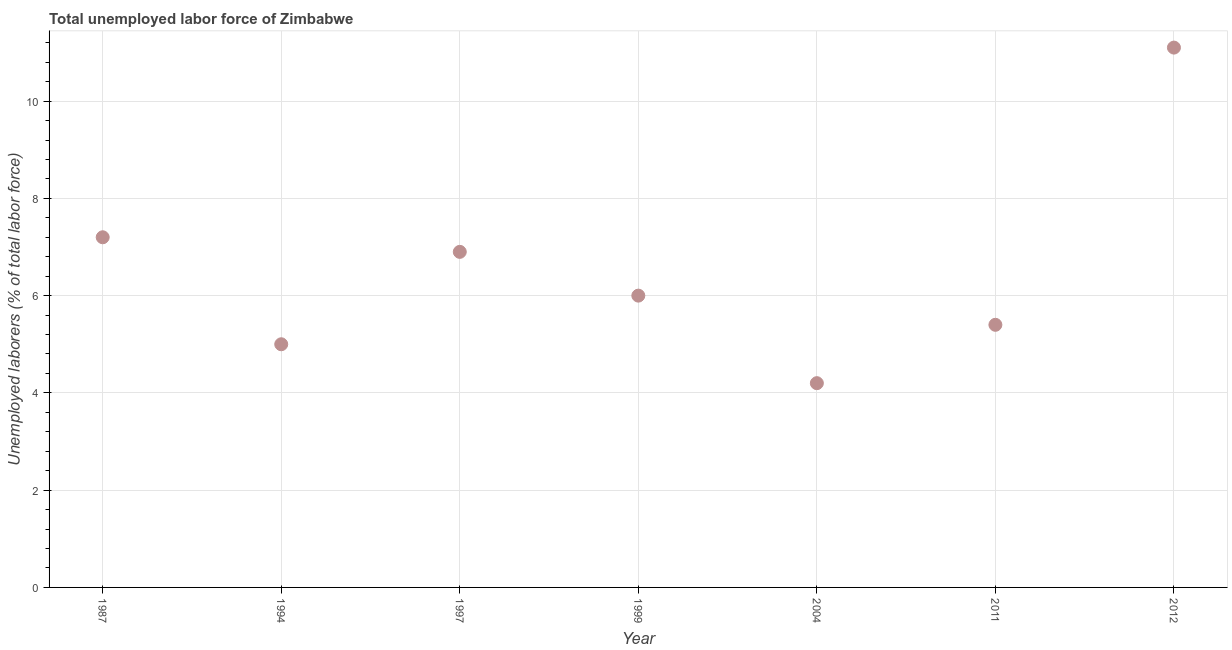What is the total unemployed labour force in 2012?
Keep it short and to the point. 11.1. Across all years, what is the maximum total unemployed labour force?
Ensure brevity in your answer.  11.1. Across all years, what is the minimum total unemployed labour force?
Your answer should be very brief. 4.2. What is the sum of the total unemployed labour force?
Offer a very short reply. 45.8. What is the difference between the total unemployed labour force in 2004 and 2012?
Provide a short and direct response. -6.9. What is the average total unemployed labour force per year?
Give a very brief answer. 6.54. What is the median total unemployed labour force?
Ensure brevity in your answer.  6. What is the ratio of the total unemployed labour force in 2004 to that in 2011?
Make the answer very short. 0.78. Is the difference between the total unemployed labour force in 1987 and 1994 greater than the difference between any two years?
Your answer should be very brief. No. What is the difference between the highest and the second highest total unemployed labour force?
Provide a short and direct response. 3.9. Is the sum of the total unemployed labour force in 1987 and 1999 greater than the maximum total unemployed labour force across all years?
Offer a terse response. Yes. What is the difference between the highest and the lowest total unemployed labour force?
Keep it short and to the point. 6.9. In how many years, is the total unemployed labour force greater than the average total unemployed labour force taken over all years?
Offer a terse response. 3. How many dotlines are there?
Your answer should be compact. 1. How many years are there in the graph?
Your response must be concise. 7. Are the values on the major ticks of Y-axis written in scientific E-notation?
Give a very brief answer. No. Does the graph contain grids?
Make the answer very short. Yes. What is the title of the graph?
Provide a short and direct response. Total unemployed labor force of Zimbabwe. What is the label or title of the X-axis?
Your answer should be very brief. Year. What is the label or title of the Y-axis?
Make the answer very short. Unemployed laborers (% of total labor force). What is the Unemployed laborers (% of total labor force) in 1987?
Ensure brevity in your answer.  7.2. What is the Unemployed laborers (% of total labor force) in 1994?
Ensure brevity in your answer.  5. What is the Unemployed laborers (% of total labor force) in 1997?
Offer a terse response. 6.9. What is the Unemployed laborers (% of total labor force) in 2004?
Give a very brief answer. 4.2. What is the Unemployed laborers (% of total labor force) in 2011?
Ensure brevity in your answer.  5.4. What is the Unemployed laborers (% of total labor force) in 2012?
Offer a terse response. 11.1. What is the difference between the Unemployed laborers (% of total labor force) in 1987 and 1994?
Ensure brevity in your answer.  2.2. What is the difference between the Unemployed laborers (% of total labor force) in 1987 and 1997?
Provide a short and direct response. 0.3. What is the difference between the Unemployed laborers (% of total labor force) in 1987 and 1999?
Give a very brief answer. 1.2. What is the difference between the Unemployed laborers (% of total labor force) in 1994 and 1999?
Provide a short and direct response. -1. What is the difference between the Unemployed laborers (% of total labor force) in 1994 and 2011?
Your answer should be compact. -0.4. What is the difference between the Unemployed laborers (% of total labor force) in 1997 and 1999?
Provide a short and direct response. 0.9. What is the difference between the Unemployed laborers (% of total labor force) in 1997 and 2004?
Your answer should be very brief. 2.7. What is the difference between the Unemployed laborers (% of total labor force) in 1997 and 2012?
Your answer should be compact. -4.2. What is the difference between the Unemployed laborers (% of total labor force) in 1999 and 2011?
Keep it short and to the point. 0.6. What is the difference between the Unemployed laborers (% of total labor force) in 1999 and 2012?
Your response must be concise. -5.1. What is the difference between the Unemployed laborers (% of total labor force) in 2004 and 2011?
Keep it short and to the point. -1.2. What is the difference between the Unemployed laborers (% of total labor force) in 2011 and 2012?
Make the answer very short. -5.7. What is the ratio of the Unemployed laborers (% of total labor force) in 1987 to that in 1994?
Offer a very short reply. 1.44. What is the ratio of the Unemployed laborers (% of total labor force) in 1987 to that in 1997?
Make the answer very short. 1.04. What is the ratio of the Unemployed laborers (% of total labor force) in 1987 to that in 2004?
Keep it short and to the point. 1.71. What is the ratio of the Unemployed laborers (% of total labor force) in 1987 to that in 2011?
Keep it short and to the point. 1.33. What is the ratio of the Unemployed laborers (% of total labor force) in 1987 to that in 2012?
Ensure brevity in your answer.  0.65. What is the ratio of the Unemployed laborers (% of total labor force) in 1994 to that in 1997?
Your response must be concise. 0.72. What is the ratio of the Unemployed laborers (% of total labor force) in 1994 to that in 1999?
Keep it short and to the point. 0.83. What is the ratio of the Unemployed laborers (% of total labor force) in 1994 to that in 2004?
Provide a short and direct response. 1.19. What is the ratio of the Unemployed laborers (% of total labor force) in 1994 to that in 2011?
Offer a terse response. 0.93. What is the ratio of the Unemployed laborers (% of total labor force) in 1994 to that in 2012?
Your answer should be very brief. 0.45. What is the ratio of the Unemployed laborers (% of total labor force) in 1997 to that in 1999?
Your answer should be very brief. 1.15. What is the ratio of the Unemployed laborers (% of total labor force) in 1997 to that in 2004?
Your response must be concise. 1.64. What is the ratio of the Unemployed laborers (% of total labor force) in 1997 to that in 2011?
Your response must be concise. 1.28. What is the ratio of the Unemployed laborers (% of total labor force) in 1997 to that in 2012?
Your answer should be compact. 0.62. What is the ratio of the Unemployed laborers (% of total labor force) in 1999 to that in 2004?
Offer a terse response. 1.43. What is the ratio of the Unemployed laborers (% of total labor force) in 1999 to that in 2011?
Make the answer very short. 1.11. What is the ratio of the Unemployed laborers (% of total labor force) in 1999 to that in 2012?
Give a very brief answer. 0.54. What is the ratio of the Unemployed laborers (% of total labor force) in 2004 to that in 2011?
Offer a terse response. 0.78. What is the ratio of the Unemployed laborers (% of total labor force) in 2004 to that in 2012?
Ensure brevity in your answer.  0.38. What is the ratio of the Unemployed laborers (% of total labor force) in 2011 to that in 2012?
Ensure brevity in your answer.  0.49. 